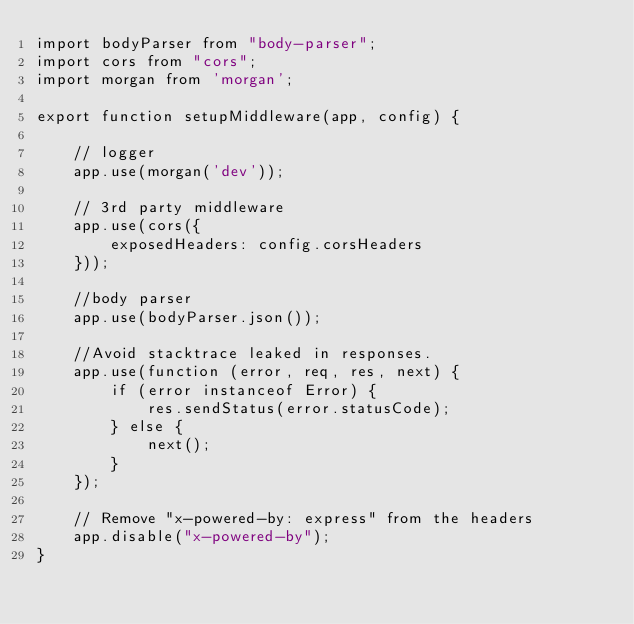<code> <loc_0><loc_0><loc_500><loc_500><_JavaScript_>import bodyParser from "body-parser";
import cors from "cors";
import morgan from 'morgan';

export function setupMiddleware(app, config) {

    // logger
    app.use(morgan('dev'));

    // 3rd party middleware
    app.use(cors({
        exposedHeaders: config.corsHeaders
    }));

    //body parser
    app.use(bodyParser.json());

    //Avoid stacktrace leaked in responses.
    app.use(function (error, req, res, next) {
        if (error instanceof Error) {
            res.sendStatus(error.statusCode);
        } else {
            next();
        }
    });

    // Remove "x-powered-by: express" from the headers
    app.disable("x-powered-by");
}</code> 